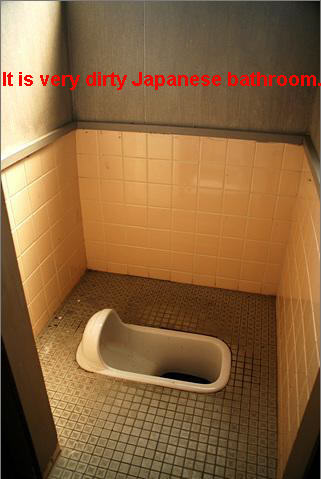Identify the text contained in this image. bathroom Japanese dirty very is It 